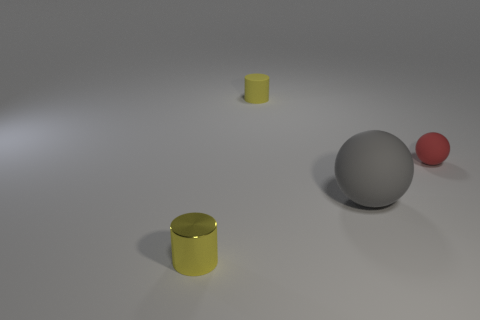The yellow matte thing that is the same size as the yellow shiny cylinder is what shape? cylinder 